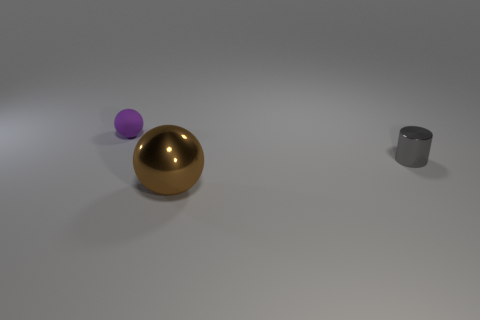Add 1 big purple metallic cylinders. How many objects exist? 4 Subtract all purple balls. How many balls are left? 1 Subtract all spheres. How many objects are left? 1 Subtract all tiny purple metallic things. Subtract all brown shiny things. How many objects are left? 2 Add 3 purple things. How many purple things are left? 4 Add 1 small gray cylinders. How many small gray cylinders exist? 2 Subtract 1 gray cylinders. How many objects are left? 2 Subtract 1 spheres. How many spheres are left? 1 Subtract all cyan balls. Subtract all red cylinders. How many balls are left? 2 